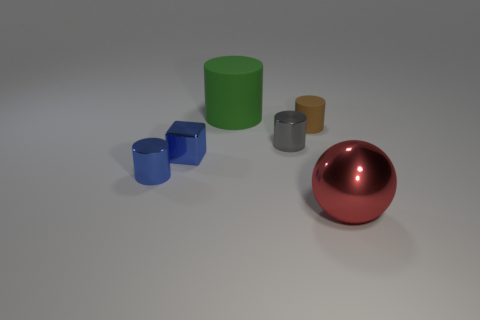There is a brown object that is the same material as the big green thing; what is its shape?
Ensure brevity in your answer.  Cylinder. How many green things are cubes or large rubber objects?
Keep it short and to the point. 1. Are there any big cylinders that are in front of the tiny metallic object that is to the right of the big thing that is to the left of the red ball?
Your answer should be compact. No. Is the number of large red metallic things less than the number of tiny gray rubber balls?
Your response must be concise. No. There is a blue metal object to the right of the tiny blue cylinder; is it the same shape as the green thing?
Your response must be concise. No. Is there a small blue metallic cube?
Provide a short and direct response. Yes. What color is the big thing that is in front of the matte cylinder in front of the object that is behind the brown matte thing?
Give a very brief answer. Red. Is the number of tiny brown matte things that are left of the gray metallic thing the same as the number of tiny blue metallic cylinders left of the green matte thing?
Keep it short and to the point. No. What shape is the other thing that is the same size as the red thing?
Your answer should be very brief. Cylinder. Are there any small objects of the same color as the tiny metallic block?
Give a very brief answer. Yes. 